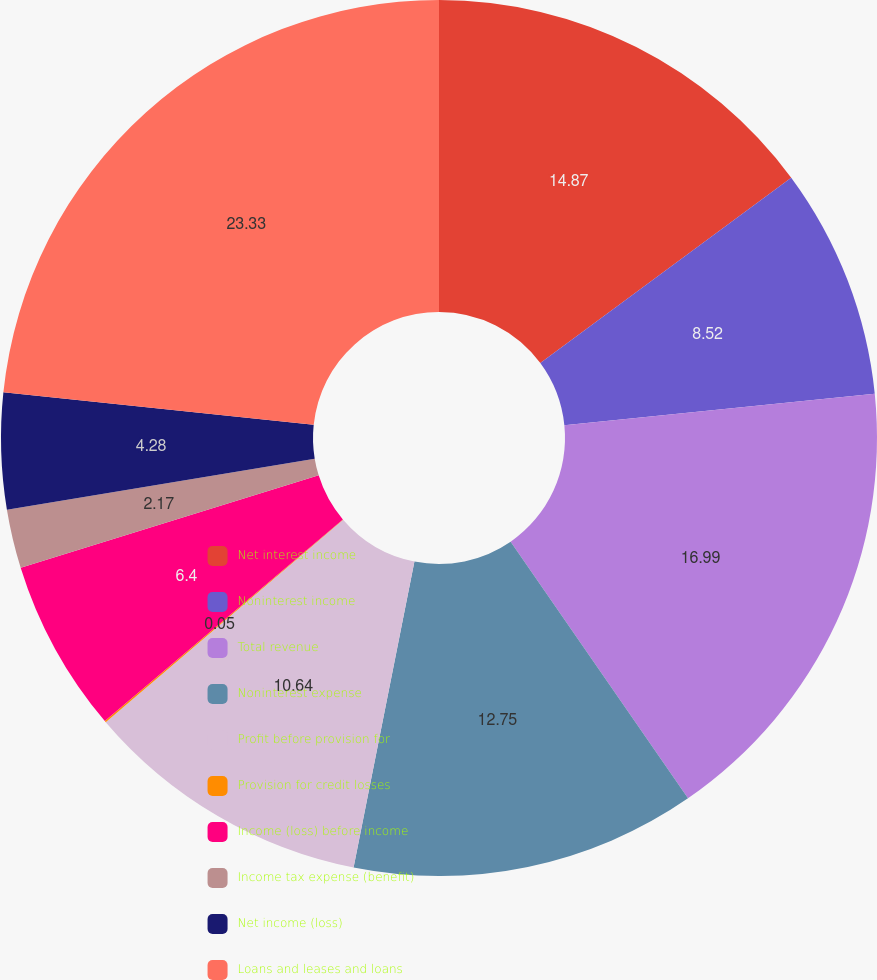Convert chart to OTSL. <chart><loc_0><loc_0><loc_500><loc_500><pie_chart><fcel>Net interest income<fcel>Noninterest income<fcel>Total revenue<fcel>Noninterest expense<fcel>Profit before provision for<fcel>Provision for credit losses<fcel>Income (loss) before income<fcel>Income tax expense (benefit)<fcel>Net income (loss)<fcel>Loans and leases and loans<nl><fcel>14.87%<fcel>8.52%<fcel>16.99%<fcel>12.75%<fcel>10.64%<fcel>0.05%<fcel>6.4%<fcel>2.17%<fcel>4.28%<fcel>23.34%<nl></chart> 